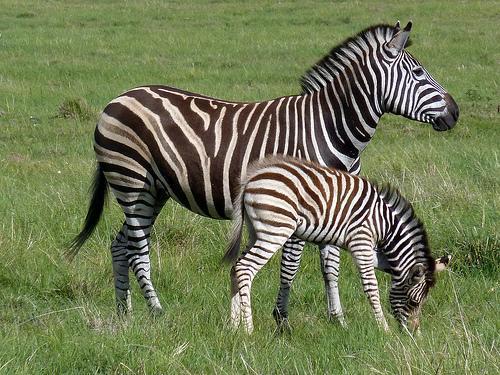How many zebras are shown?
Give a very brief answer. 2. 